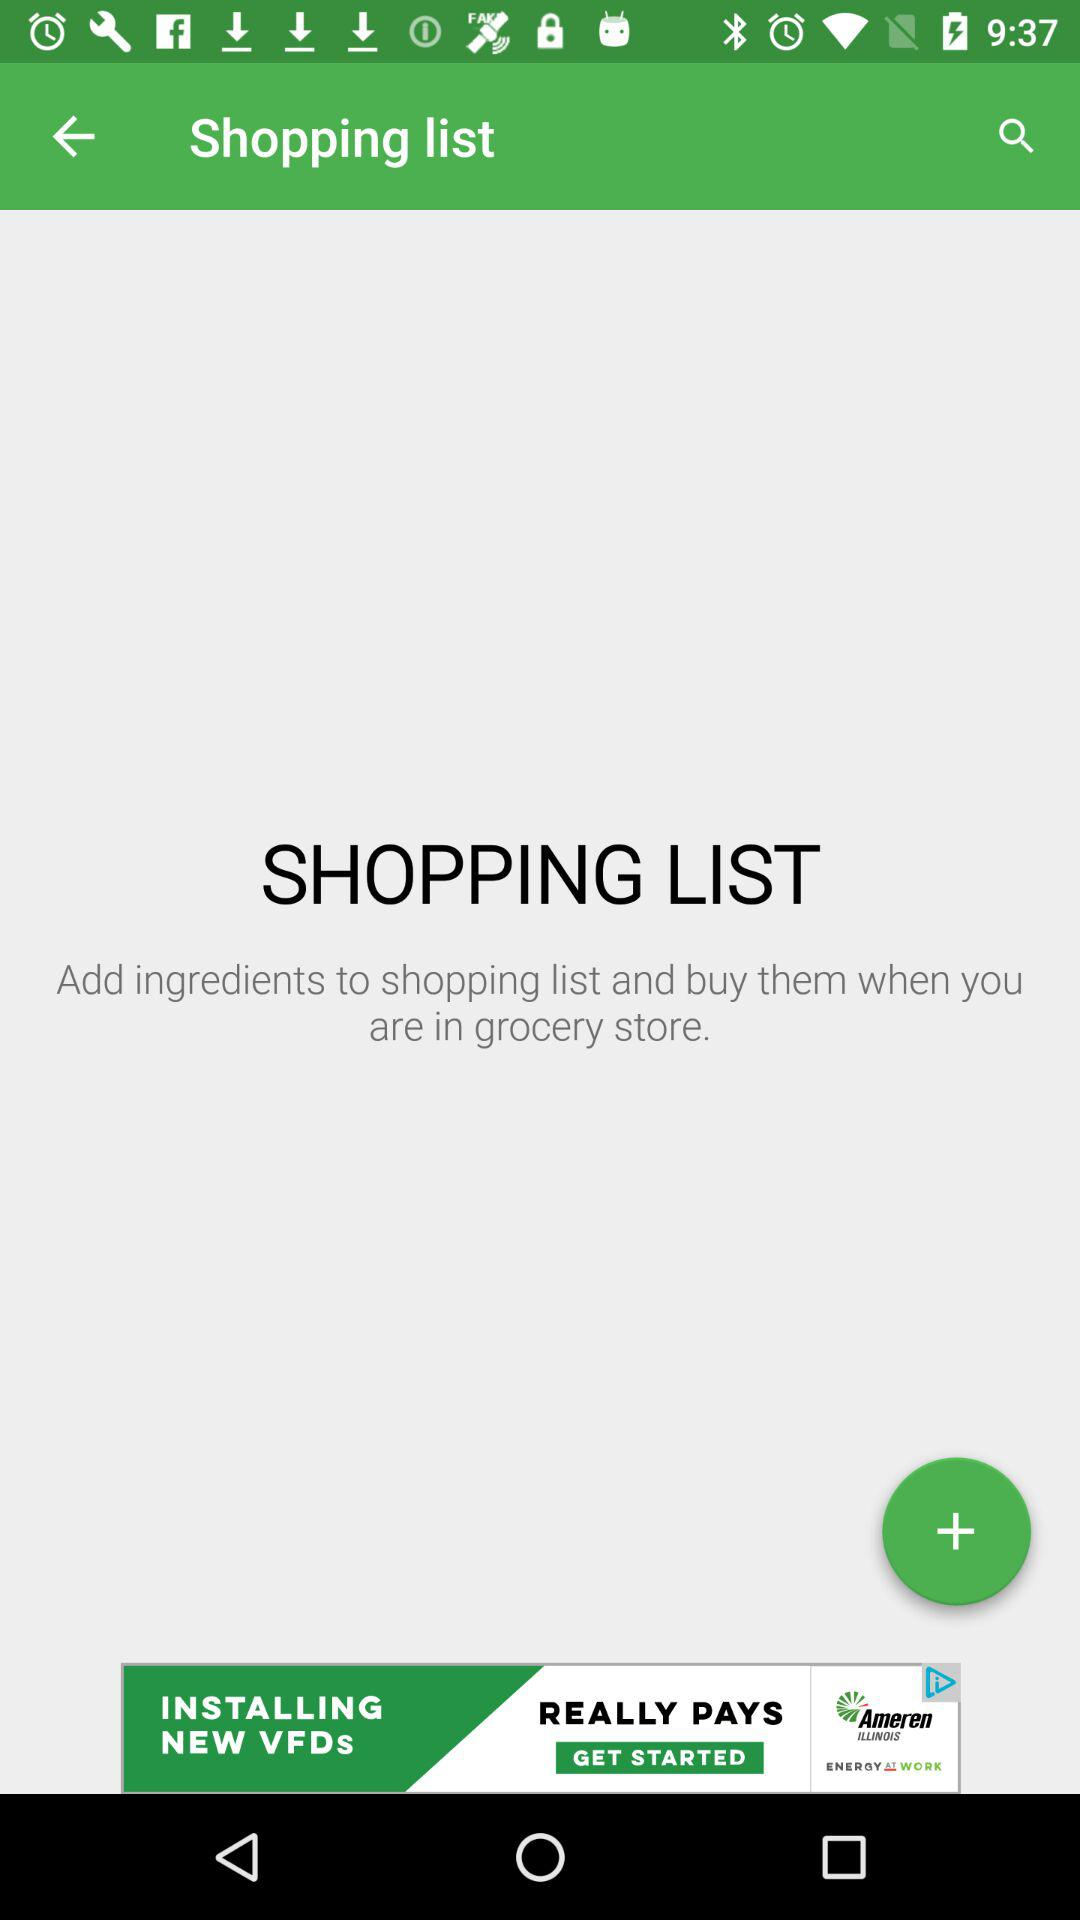In what list are the ingredients to be added? The ingredients are added to the shopping list. 